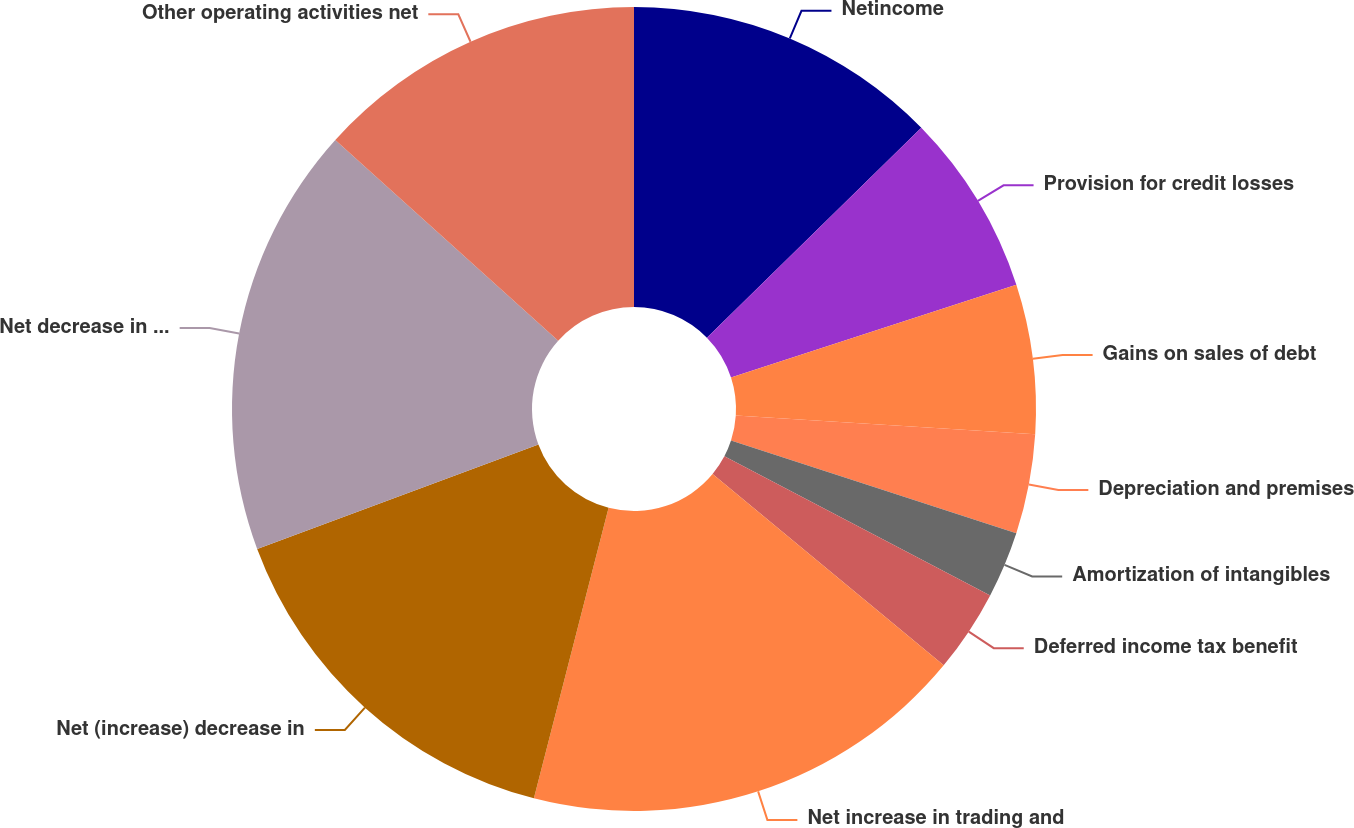Convert chart to OTSL. <chart><loc_0><loc_0><loc_500><loc_500><pie_chart><fcel>Netincome<fcel>Provision for credit losses<fcel>Gains on sales of debt<fcel>Depreciation and premises<fcel>Amortization of intangibles<fcel>Deferred income tax benefit<fcel>Net increase in trading and<fcel>Net (increase) decrease in<fcel>Net decrease in accrued<fcel>Other operating activities net<nl><fcel>12.67%<fcel>7.33%<fcel>6.0%<fcel>4.0%<fcel>2.67%<fcel>3.33%<fcel>18.0%<fcel>15.33%<fcel>17.33%<fcel>13.33%<nl></chart> 